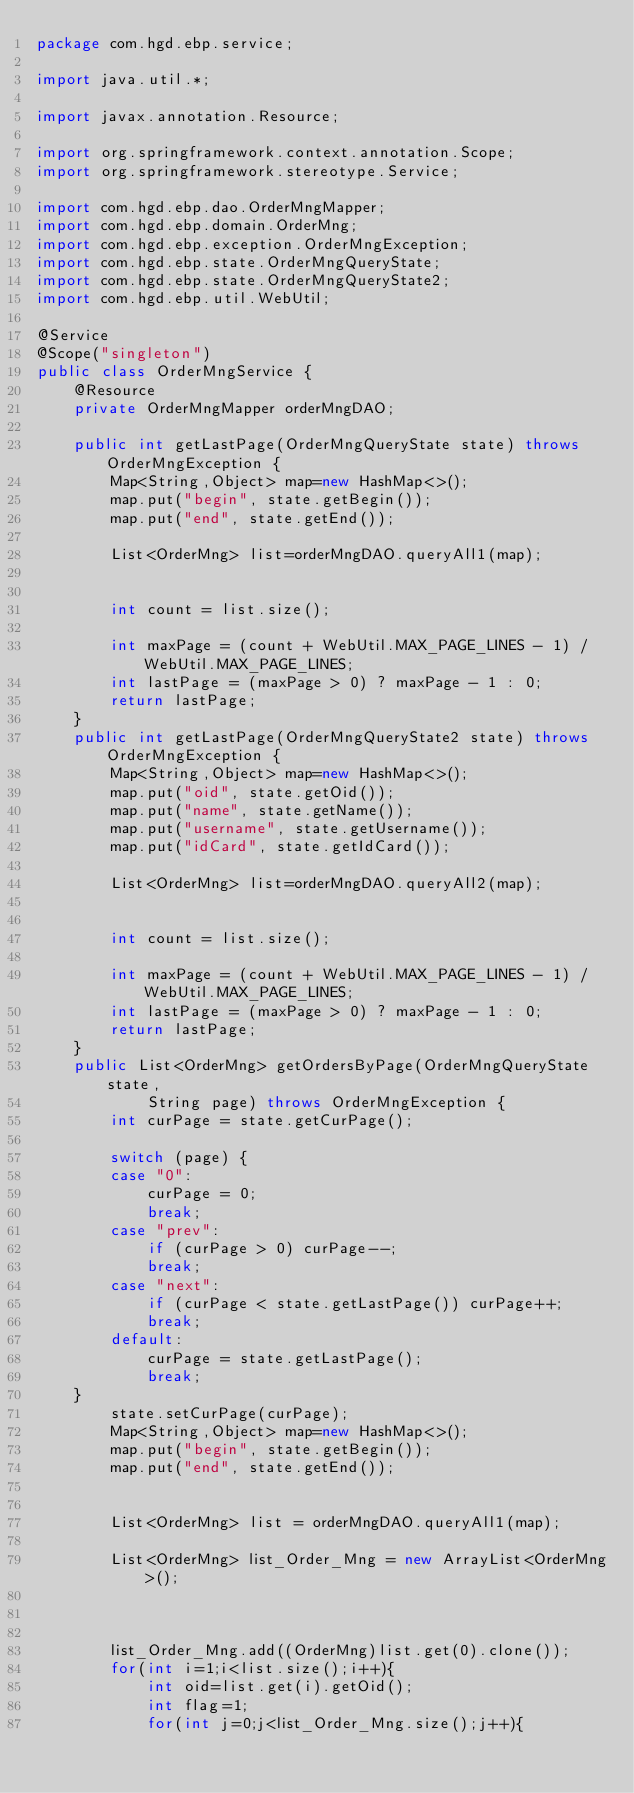<code> <loc_0><loc_0><loc_500><loc_500><_Java_>package com.hgd.ebp.service;

import java.util.*;

import javax.annotation.Resource;

import org.springframework.context.annotation.Scope;
import org.springframework.stereotype.Service;

import com.hgd.ebp.dao.OrderMngMapper;
import com.hgd.ebp.domain.OrderMng;
import com.hgd.ebp.exception.OrderMngException;
import com.hgd.ebp.state.OrderMngQueryState;
import com.hgd.ebp.state.OrderMngQueryState2;
import com.hgd.ebp.util.WebUtil;

@Service
@Scope("singleton")
public class OrderMngService {
	@Resource
	private OrderMngMapper orderMngDAO;
		
	public int getLastPage(OrderMngQueryState state) throws OrderMngException {
		Map<String,Object> map=new HashMap<>();
		map.put("begin", state.getBegin());
		map.put("end", state.getEnd());
		
		List<OrderMng> list=orderMngDAO.queryAll1(map);
		
		
		int count = list.size();
		
		int maxPage = (count + WebUtil.MAX_PAGE_LINES - 1) / WebUtil.MAX_PAGE_LINES;
		int lastPage = (maxPage > 0) ? maxPage - 1 : 0;  
        return lastPage;
	}
	public int getLastPage(OrderMngQueryState2 state) throws OrderMngException {
		Map<String,Object> map=new HashMap<>();
		map.put("oid", state.getOid());
		map.put("name", state.getName());
		map.put("username", state.getUsername());
		map.put("idCard", state.getIdCard());
		
		List<OrderMng> list=orderMngDAO.queryAll2(map);
		
		
		int count = list.size();
		
		int maxPage = (count + WebUtil.MAX_PAGE_LINES - 1) / WebUtil.MAX_PAGE_LINES;
		int lastPage = (maxPage > 0) ? maxPage - 1 : 0;  
        return lastPage;
	}
	public List<OrderMng> getOrdersByPage(OrderMngQueryState state, 
			String page) throws OrderMngException {
		int curPage = state.getCurPage();
		
		switch (page) {
		case "0":
			curPage = 0;
			break;
		case "prev":
			if (curPage > 0) curPage--;
			break;
		case "next":
			if (curPage < state.getLastPage()) curPage++;
			break;
		default:
			curPage = state.getLastPage();
			break;
	}
		state.setCurPage(curPage);
		Map<String,Object> map=new HashMap<>();
		map.put("begin", state.getBegin());
		map.put("end", state.getEnd());
		
		
		List<OrderMng> list = orderMngDAO.queryAll1(map);
		
		List<OrderMng> list_Order_Mng = new ArrayList<OrderMng>(); 
		
		
		
		list_Order_Mng.add((OrderMng)list.get(0).clone());
		for(int i=1;i<list.size();i++){
			int oid=list.get(i).getOid();
			int flag=1;
			for(int j=0;j<list_Order_Mng.size();j++){</code> 